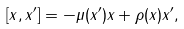Convert formula to latex. <formula><loc_0><loc_0><loc_500><loc_500>[ x , x ^ { \prime } ] = - \mu ( x ^ { \prime } ) x + \rho ( x ) x ^ { \prime } ,</formula> 